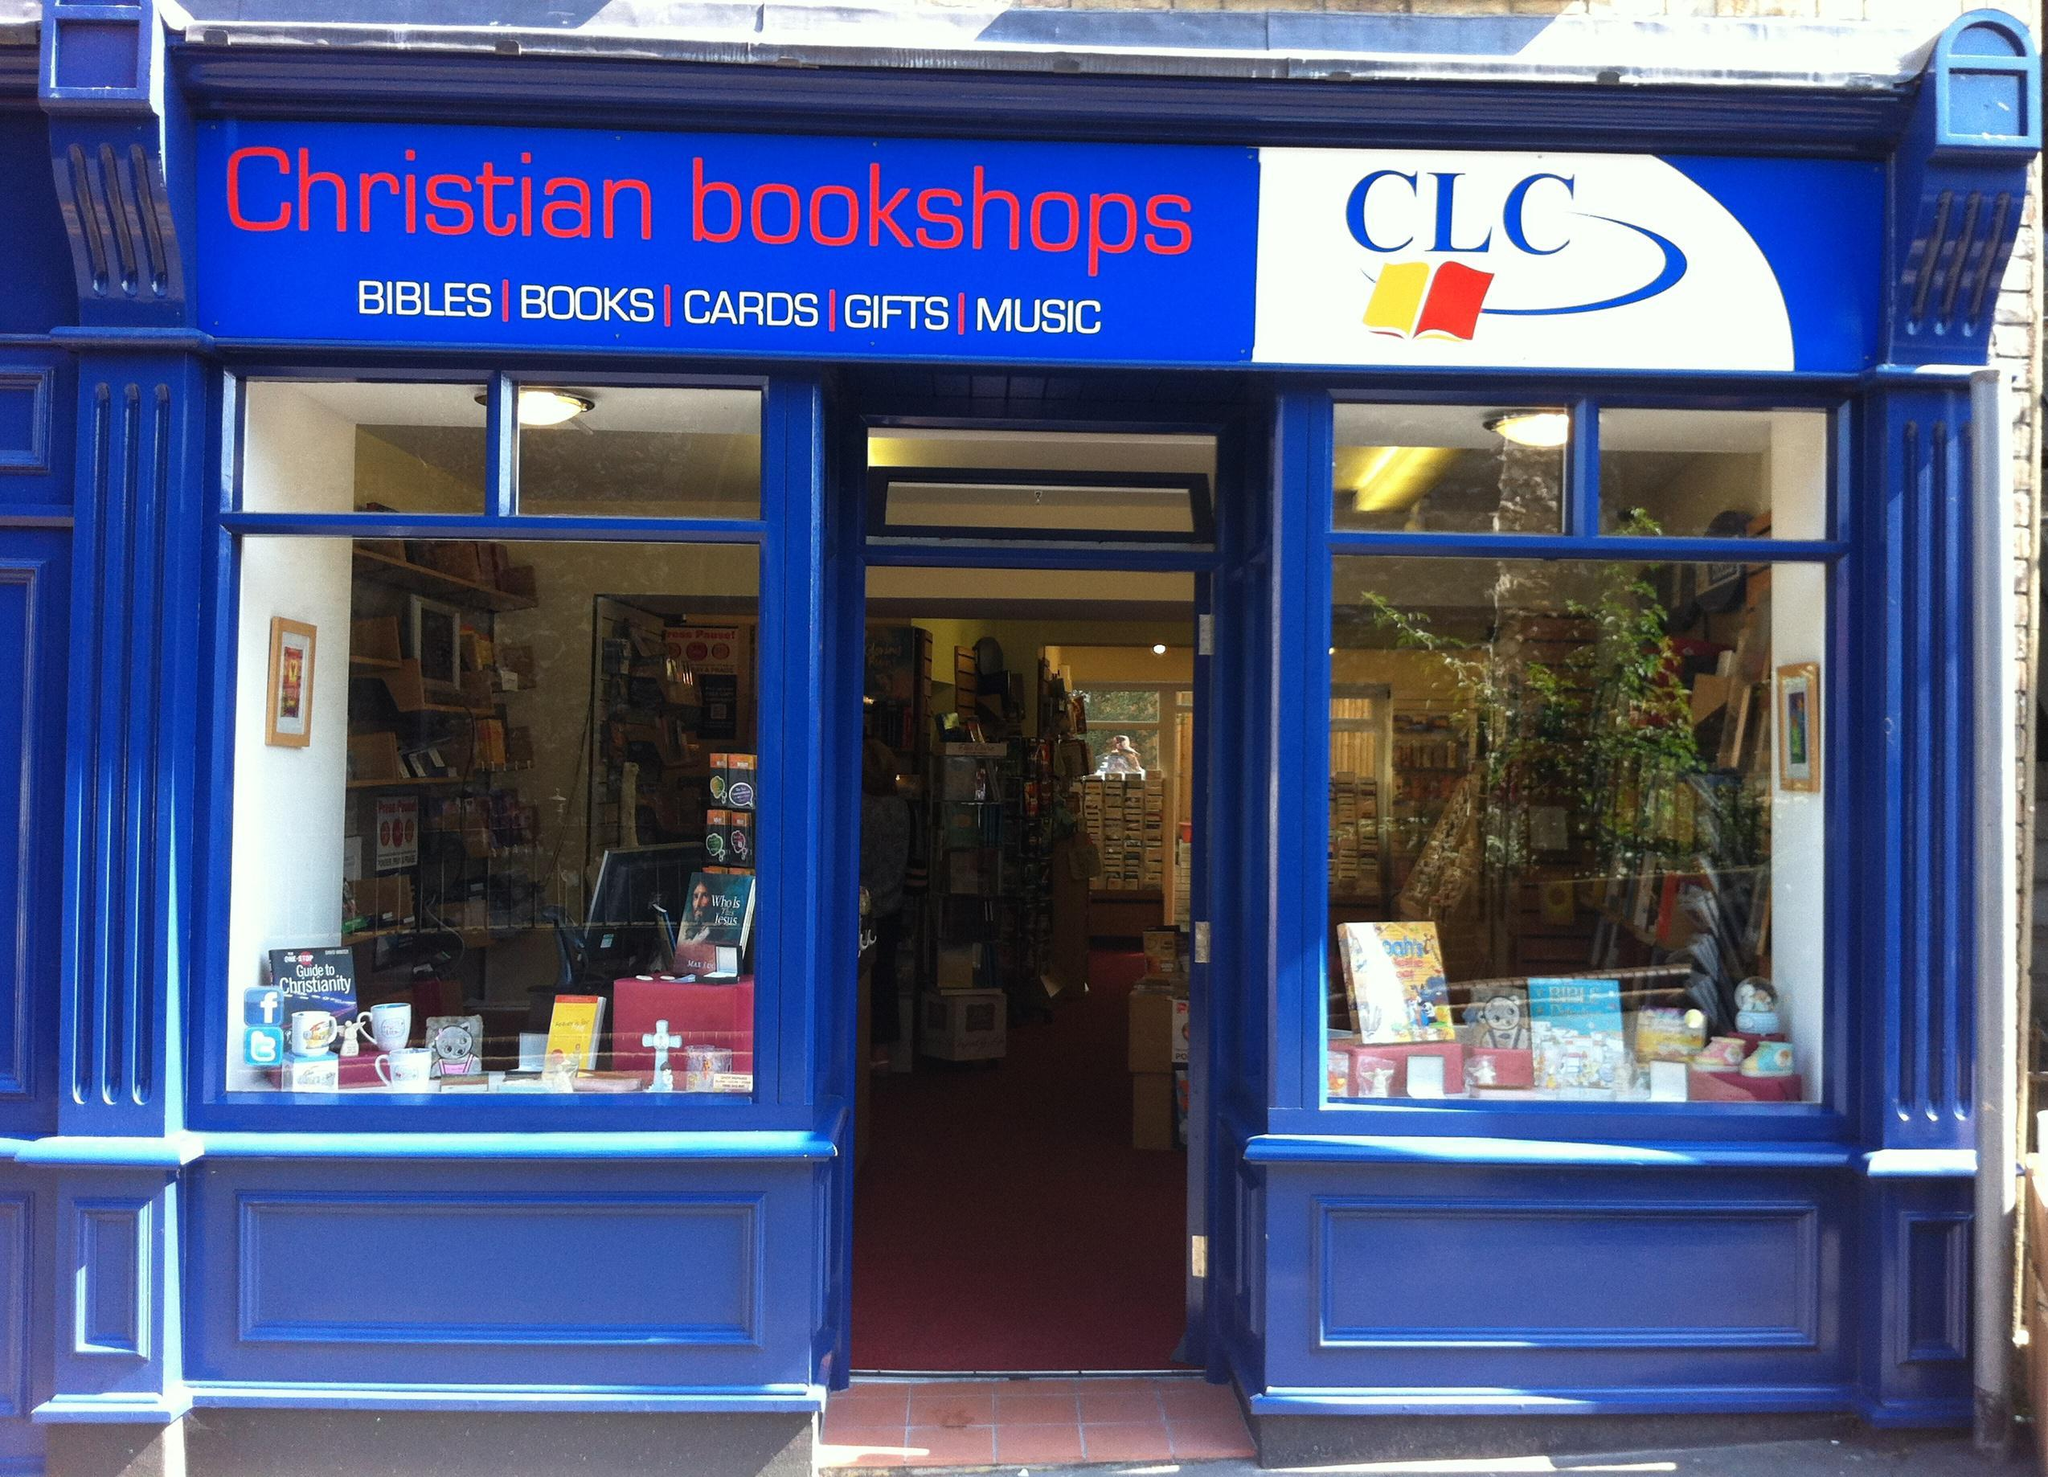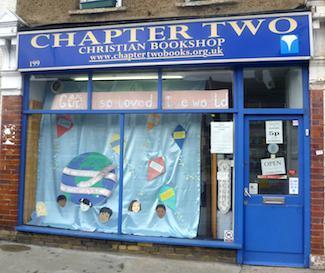The first image is the image on the left, the second image is the image on the right. Given the left and right images, does the statement "The right image shows a bookstore with a blue exterior, a large display window only to the left of one door, and four rectangular panes of glass under its sign." hold true? Answer yes or no. Yes. 